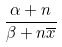Convert formula to latex. <formula><loc_0><loc_0><loc_500><loc_500>\frac { \alpha + n } { \beta + n \overline { x } }</formula> 